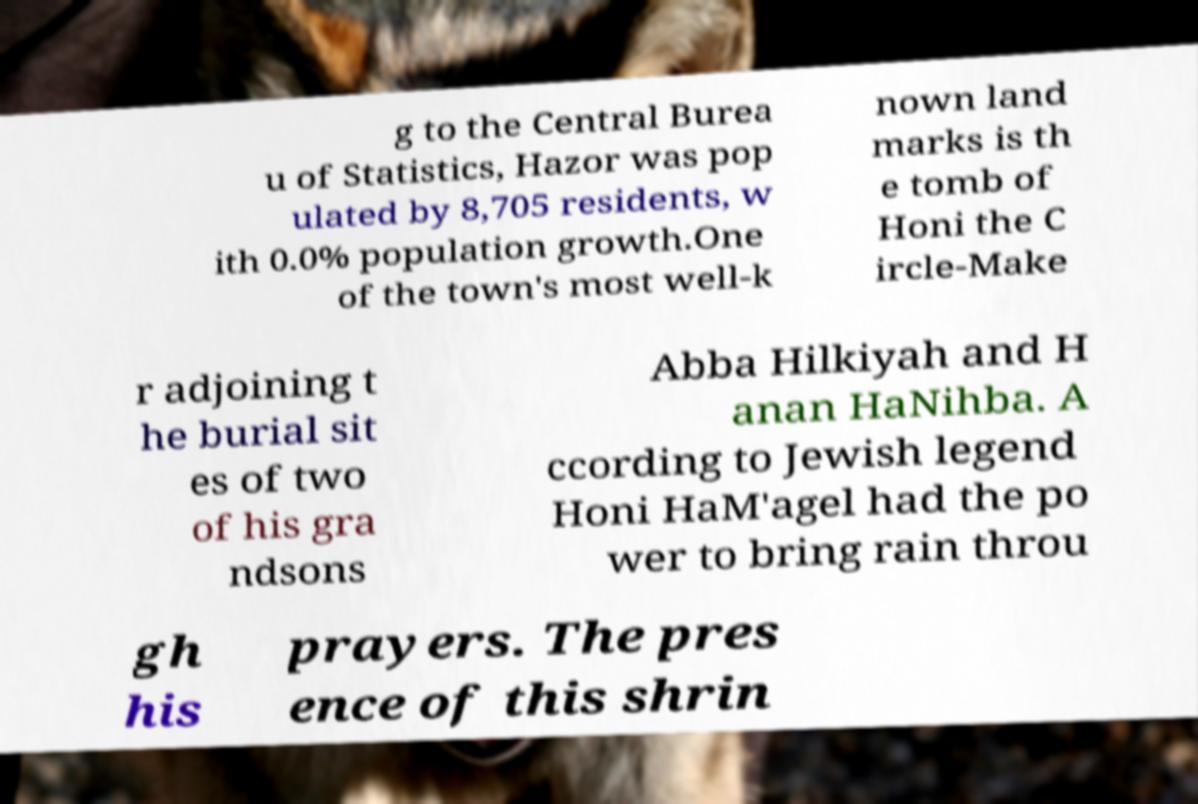Could you assist in decoding the text presented in this image and type it out clearly? g to the Central Burea u of Statistics, Hazor was pop ulated by 8,705 residents, w ith 0.0% population growth.One of the town's most well-k nown land marks is th e tomb of Honi the C ircle-Make r adjoining t he burial sit es of two of his gra ndsons Abba Hilkiyah and H anan HaNihba. A ccording to Jewish legend Honi HaM'agel had the po wer to bring rain throu gh his prayers. The pres ence of this shrin 